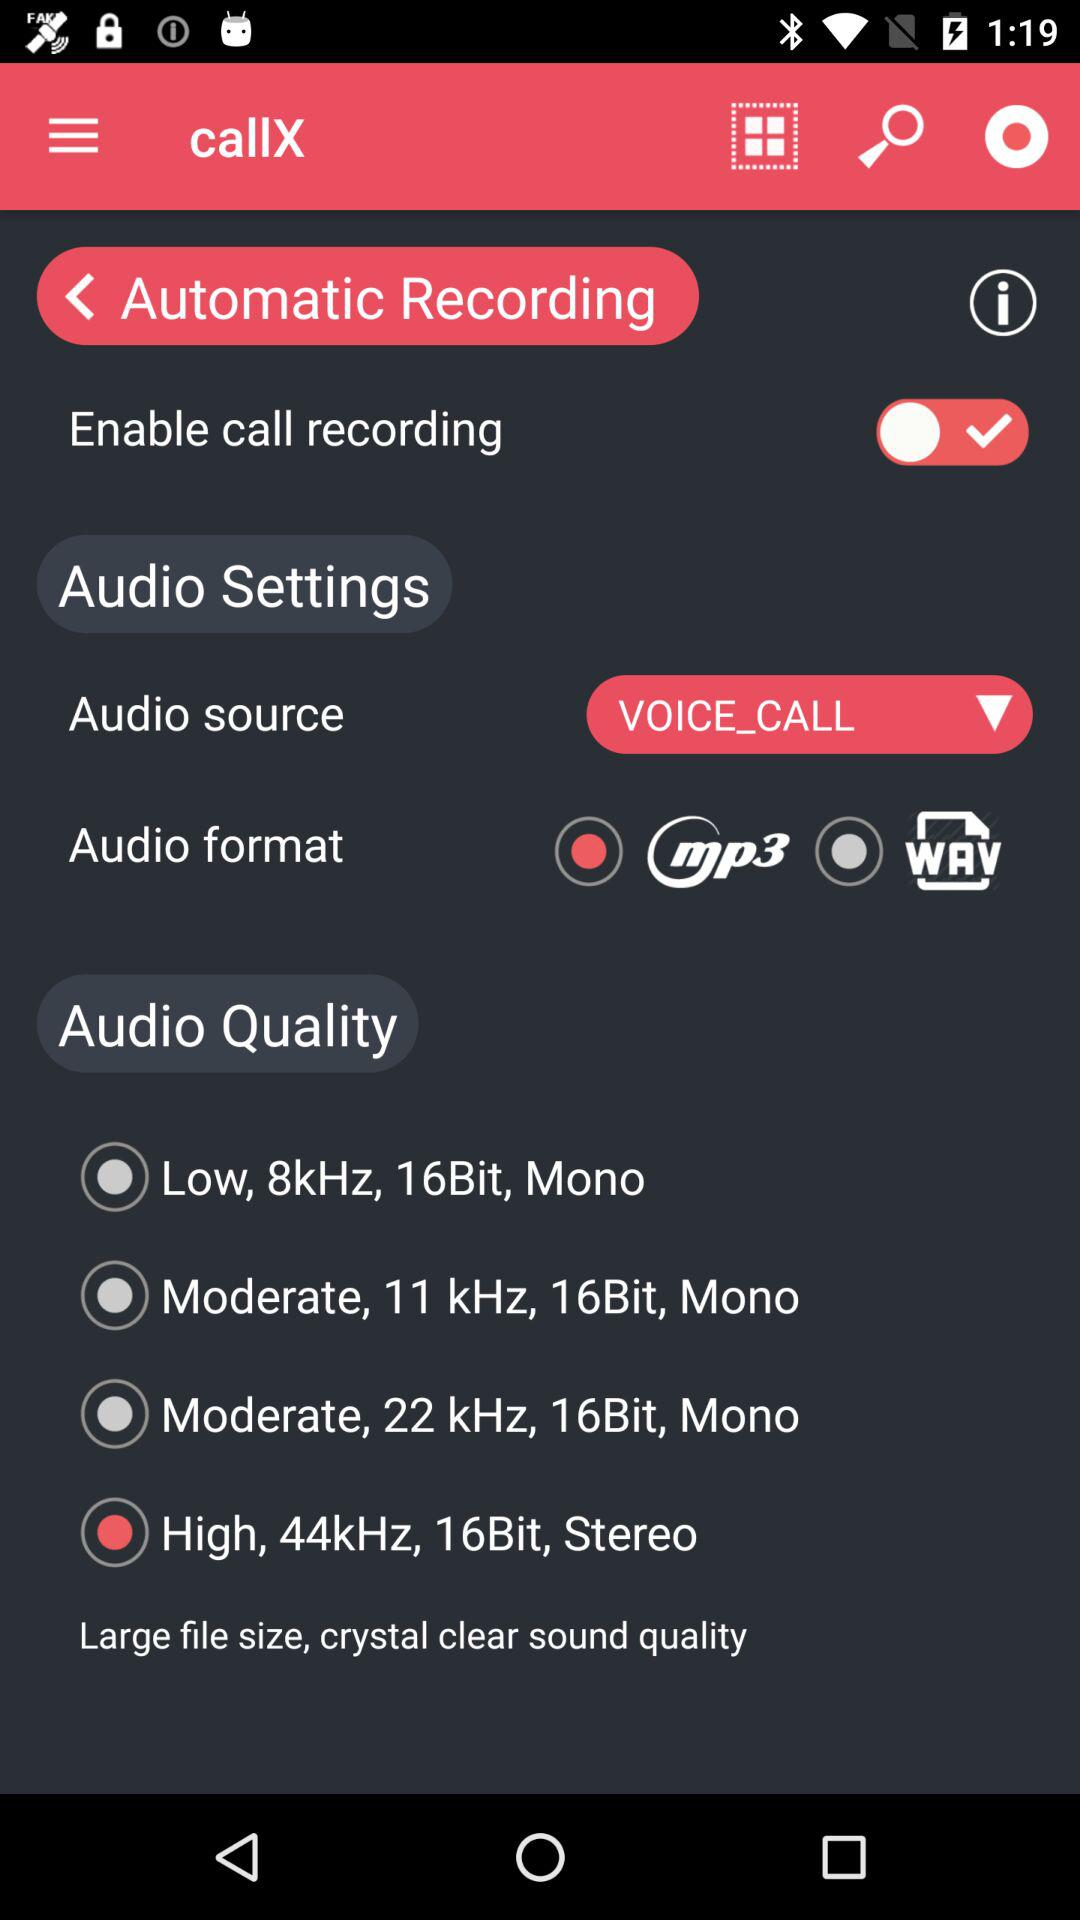How many audio quality options are there?
Answer the question using a single word or phrase. 4 